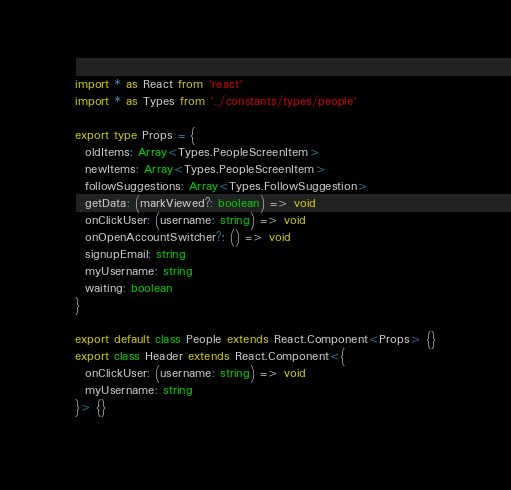Convert code to text. <code><loc_0><loc_0><loc_500><loc_500><_TypeScript_>import * as React from 'react'
import * as Types from '../constants/types/people'

export type Props = {
  oldItems: Array<Types.PeopleScreenItem>
  newItems: Array<Types.PeopleScreenItem>
  followSuggestions: Array<Types.FollowSuggestion>
  getData: (markViewed?: boolean) => void
  onClickUser: (username: string) => void
  onOpenAccountSwitcher?: () => void
  signupEmail: string
  myUsername: string
  waiting: boolean
}

export default class People extends React.Component<Props> {}
export class Header extends React.Component<{
  onClickUser: (username: string) => void
  myUsername: string
}> {}
</code> 